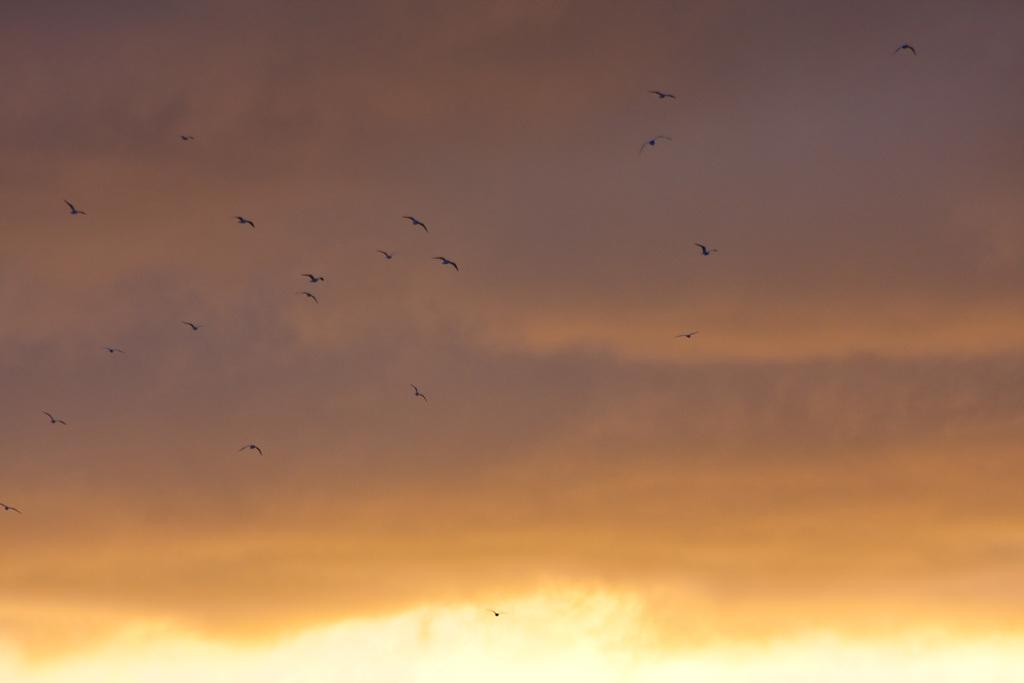What is the main subject of the image? The main subject of the image is a group of birds. What are the birds doing in the image? The birds are flying in the sky. How would you describe the sky in the image? The sky appears to be cloudy. What type of coal can be seen in the image? There is no coal present in the image. How does the soap help the birds in the image? There is no soap or indication of any assistance to the birds in the image. 